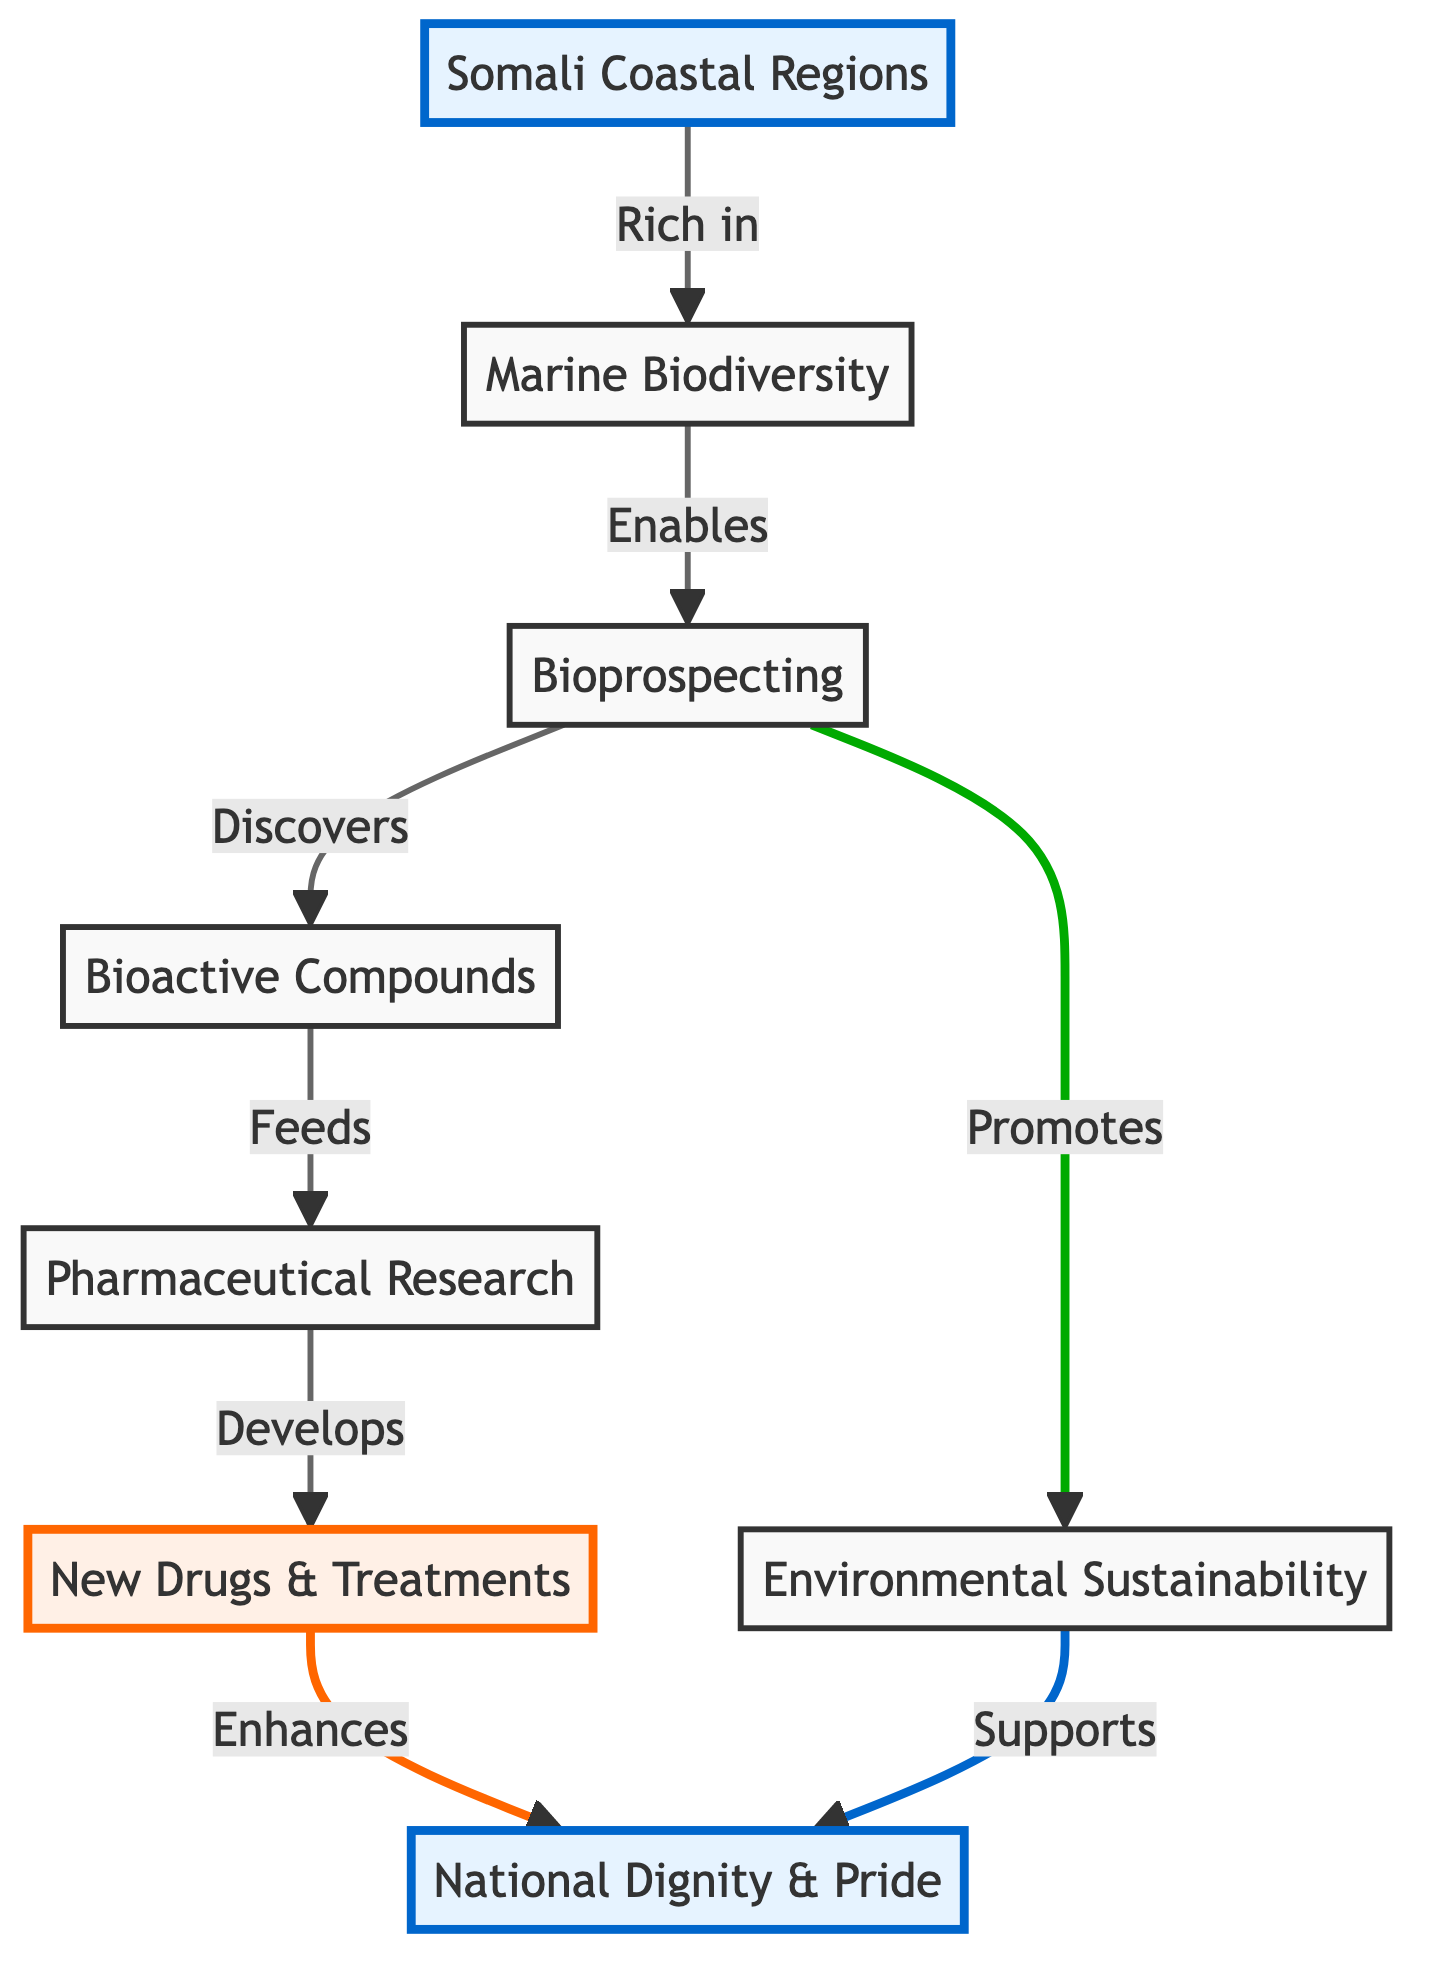What do Somali coastal regions lead to? The Somali coastal regions are connected to marine biodiversity in the diagram, indicating that these regions contribute significantly to the variety of marine life found there.
Answer: Marine biodiversity What does bioprospecting discover? According to the diagram, bioprospecting is shown to discover bioactive compounds, highlighting its role in exploring marine resources for chemical activities relevant to medicine.
Answer: Bioactive compounds How many main components are shown in the diagram? Counting the nodes in the diagram, there are a total of six main components: Somali coastal regions, marine biodiversity, bioprospecting, bioactive compounds, pharmaceutical research, and new drugs & treatments, along with the aspects of environmental sustainability and national dignity & pride.
Answer: Six What does new drugs & treatments enhance? The diagram specifically indicates that new drugs & treatments enhance national dignity & pride, showing a connection between pharmaceutical advancements and the cultural or national implications for Somalia.
Answer: National dignity & pride How does environmental sustainability support national pride? The diagram illustrates that environmental sustainability directly supports national dignity & pride, establishing a link between responsible environmental practices and the promotion of national integrity and esteem.
Answer: National dignity & pride What role does pharmaceutical research have? The diagram distinctly defines the role of pharmaceutical research as developing new drugs & treatments, showing its significance in the progression from discovery to application in medicine.
Answer: Develops What three actions followed bioprospecting in the diagram? From bioprospecting, the actions that follow are discovering bioactive compounds, promoting environmental sustainability, and feeding pharmaceutical research, indicating multiple pathways stemming from bioprospecting.
Answer: Discover, Promote, Feed What relationship connects marine biodiversity and environmental sustainability? The relationship shown in the diagram shows that marine biodiversity enables bioprospecting, which in turn promotes environmental sustainability, indicating a supportive link between marine life and ecological practices.
Answer: Promotes Which aspect does pharmaceutical research feed into? The diagram shows that pharmaceutical research is fed by bioactive compounds, highlighting the reliance of drug development on discoveries made through bioprospecting within marine biodiversity.
Answer: Bioactive compounds 